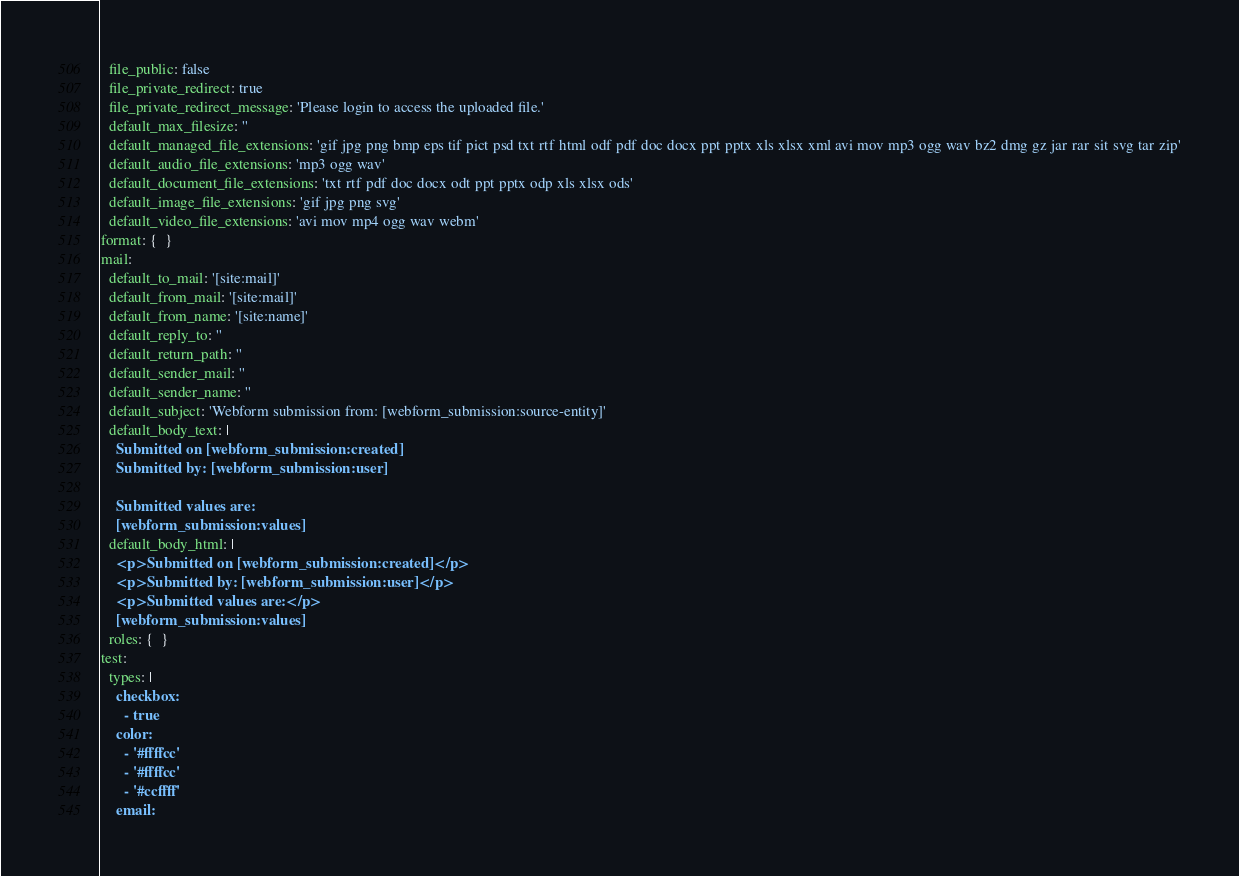Convert code to text. <code><loc_0><loc_0><loc_500><loc_500><_YAML_>  file_public: false
  file_private_redirect: true
  file_private_redirect_message: 'Please login to access the uploaded file.'
  default_max_filesize: ''
  default_managed_file_extensions: 'gif jpg png bmp eps tif pict psd txt rtf html odf pdf doc docx ppt pptx xls xlsx xml avi mov mp3 ogg wav bz2 dmg gz jar rar sit svg tar zip'
  default_audio_file_extensions: 'mp3 ogg wav'
  default_document_file_extensions: 'txt rtf pdf doc docx odt ppt pptx odp xls xlsx ods'
  default_image_file_extensions: 'gif jpg png svg'
  default_video_file_extensions: 'avi mov mp4 ogg wav webm'
format: {  }
mail:
  default_to_mail: '[site:mail]'
  default_from_mail: '[site:mail]'
  default_from_name: '[site:name]'
  default_reply_to: ''
  default_return_path: ''
  default_sender_mail: ''
  default_sender_name: ''
  default_subject: 'Webform submission from: [webform_submission:source-entity]'
  default_body_text: |
    Submitted on [webform_submission:created]
    Submitted by: [webform_submission:user]
    
    Submitted values are:
    [webform_submission:values]
  default_body_html: |
    <p>Submitted on [webform_submission:created]</p>
    <p>Submitted by: [webform_submission:user]</p>
    <p>Submitted values are:</p>
    [webform_submission:values]
  roles: {  }
test:
  types: |
    checkbox:
      - true
    color:
      - '#ffffcc'
      - '#ffffcc'
      - '#ccffff'
    email:</code> 